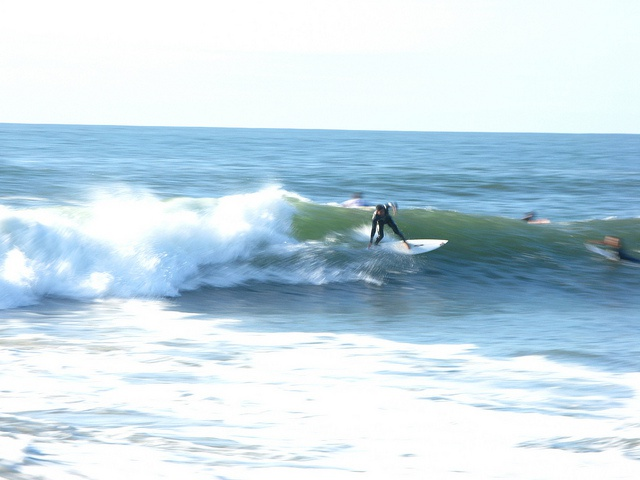Describe the objects in this image and their specific colors. I can see people in white, navy, gray, darkblue, and blue tones, surfboard in white, lightblue, and gray tones, people in white, gray, darkblue, and blue tones, surfboard in white, gray, and darkgray tones, and surfboard in white, darkgray, gray, and lightgray tones in this image. 